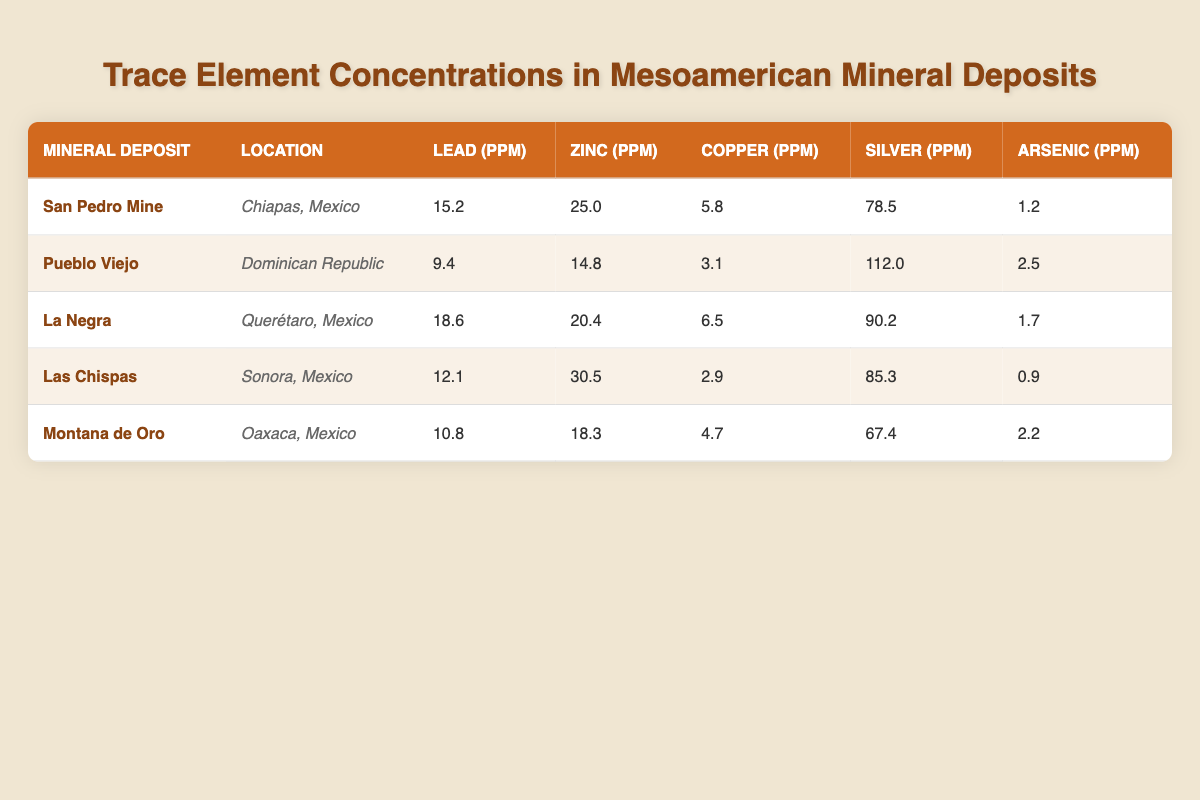what is the lead concentration in La Negra? The table indicates that La Negra has a lead concentration of 18.6 ppm.
Answer: 18.6 ppm which mineral deposit has the highest silver concentration? According to the table, Pueblo Viejo has the highest silver concentration at 112.0 ppm, compared to the other deposits.
Answer: Pueblo Viejo calculate the average zinc concentration across all mineral deposits. Adding the zinc concentrations from all five deposits: 25.0 + 14.8 + 20.4 + 30.5 + 18.3 = 109.0 pm. Then, dividing by the number of deposits, 109.0 / 5 = 21.8 ppm.
Answer: 21.8 ppm is the copper concentration in Montana de Oro higher than that in Las Chispas? Montana de Oro has a copper concentration of 4.7 ppm, while Las Chispas has 2.9 ppm. Since 4.7 is greater than 2.9, the statement is true.
Answer: Yes what is the difference in lead concentration between San Pedro Mine and Las Chispas? The lead concentration in San Pedro Mine is 15.2 ppm and in Las Chispas is 12.1 ppm. The difference is 15.2 - 12.1 = 3.1 ppm.
Answer: 3.1 ppm which location has the lowest arsenic concentration? Reviewing the arsenic concentrations, Las Chispas has the lowest at 0.9 ppm compared to the other locations.
Answer: Las Chispas if we sum the silver concentrations from all deposits, what would that value be? The silver concentrations are summed as follows: 78.5 + 112.0 + 90.2 + 85.3 + 67.4 = 433.4 ppm.
Answer: 433.4 ppm are there any mineral deposits with arsenic concentrations higher than 2 ppm? Only Pueblo Viejo and Montana de Oro have arsenic concentrations of 2.5 ppm and 2.2 ppm respectively, so the answer is yes.
Answer: Yes which mineral deposit has the lowest zinc concentration? The table shows that Pueblo Viejo has a zinc concentration of 14.8 ppm, which is the lowest among the other deposits listed.
Answer: Pueblo Viejo 